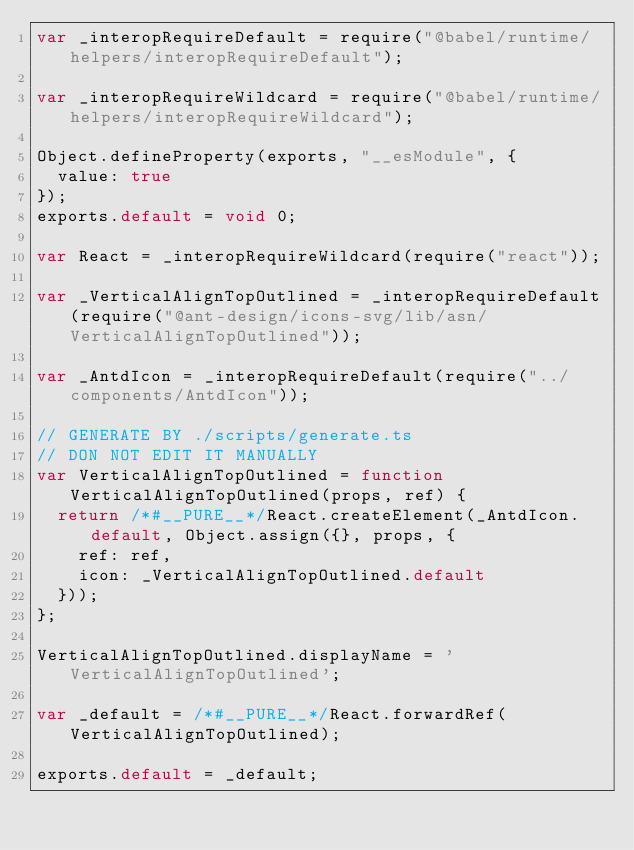<code> <loc_0><loc_0><loc_500><loc_500><_JavaScript_>var _interopRequireDefault = require("@babel/runtime/helpers/interopRequireDefault");

var _interopRequireWildcard = require("@babel/runtime/helpers/interopRequireWildcard");

Object.defineProperty(exports, "__esModule", {
  value: true
});
exports.default = void 0;

var React = _interopRequireWildcard(require("react"));

var _VerticalAlignTopOutlined = _interopRequireDefault(require("@ant-design/icons-svg/lib/asn/VerticalAlignTopOutlined"));

var _AntdIcon = _interopRequireDefault(require("../components/AntdIcon"));

// GENERATE BY ./scripts/generate.ts
// DON NOT EDIT IT MANUALLY
var VerticalAlignTopOutlined = function VerticalAlignTopOutlined(props, ref) {
  return /*#__PURE__*/React.createElement(_AntdIcon.default, Object.assign({}, props, {
    ref: ref,
    icon: _VerticalAlignTopOutlined.default
  }));
};

VerticalAlignTopOutlined.displayName = 'VerticalAlignTopOutlined';

var _default = /*#__PURE__*/React.forwardRef(VerticalAlignTopOutlined);

exports.default = _default;</code> 